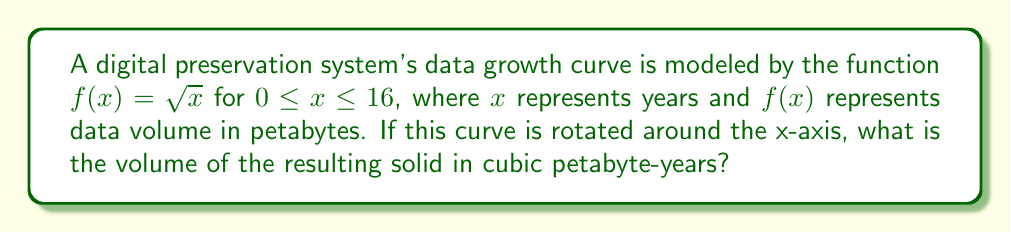Teach me how to tackle this problem. To solve this problem, we'll use the washer method for calculating the volume of a solid of revolution:

1) The formula for the volume of a solid formed by rotating a function $f(x)$ around the x-axis from $a$ to $b$ is:

   $$V = \pi \int_a^b [f(x)]^2 dx$$

2) In our case, $f(x) = \sqrt{x}$, $a = 0$, and $b = 16$. Let's substitute these into the formula:

   $$V = \pi \int_0^{16} (\sqrt{x})^2 dx$$

3) Simplify the integrand:

   $$V = \pi \int_0^{16} x dx$$

4) Integrate:

   $$V = \pi \left[\frac{1}{2}x^2\right]_0^{16}$$

5) Evaluate the definite integral:

   $$V = \pi \left(\frac{1}{2}(16)^2 - \frac{1}{2}(0)^2\right)$$

6) Simplify:

   $$V = \pi (128 - 0) = 128\pi$$

Therefore, the volume of the solid is $128\pi$ cubic petabyte-years.
Answer: $128\pi$ cubic petabyte-years 